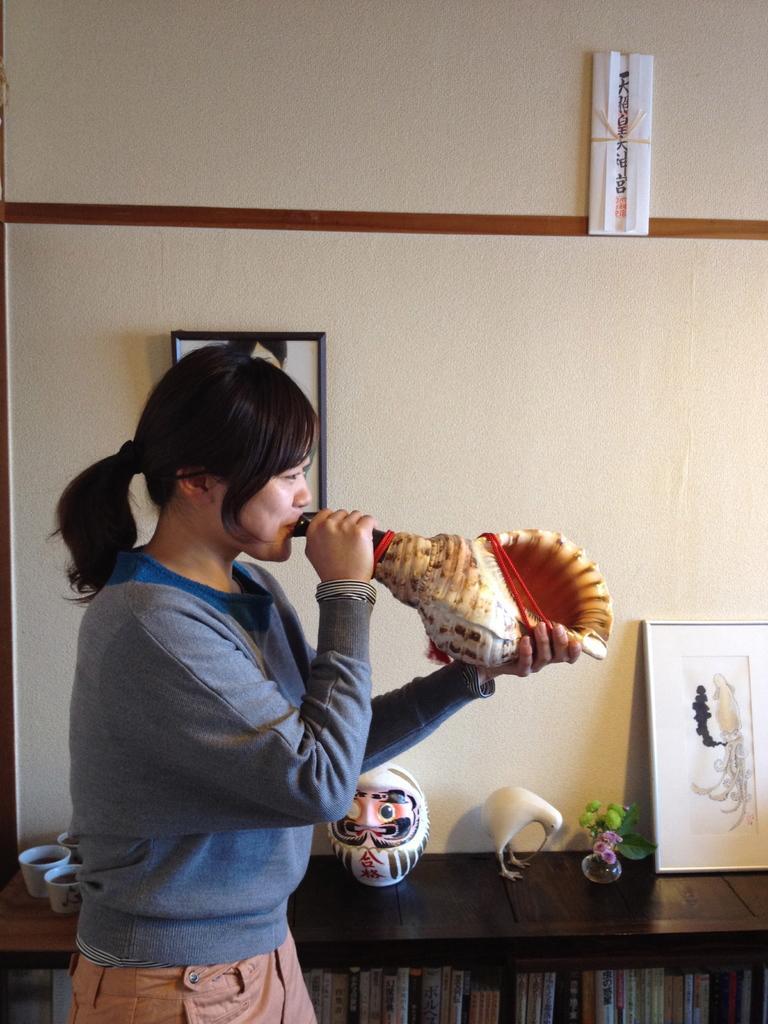In one or two sentences, can you explain what this image depicts? In this image we can see a lady holding a shell in the hand. In the back there is a cupboard. In the cupboard there are books. On the cupboard there are cups, mask, statue of a bird, vase with flowers and a photo frame. In the back there is a wall with photo frame. Also there is some other thing on the wall. 